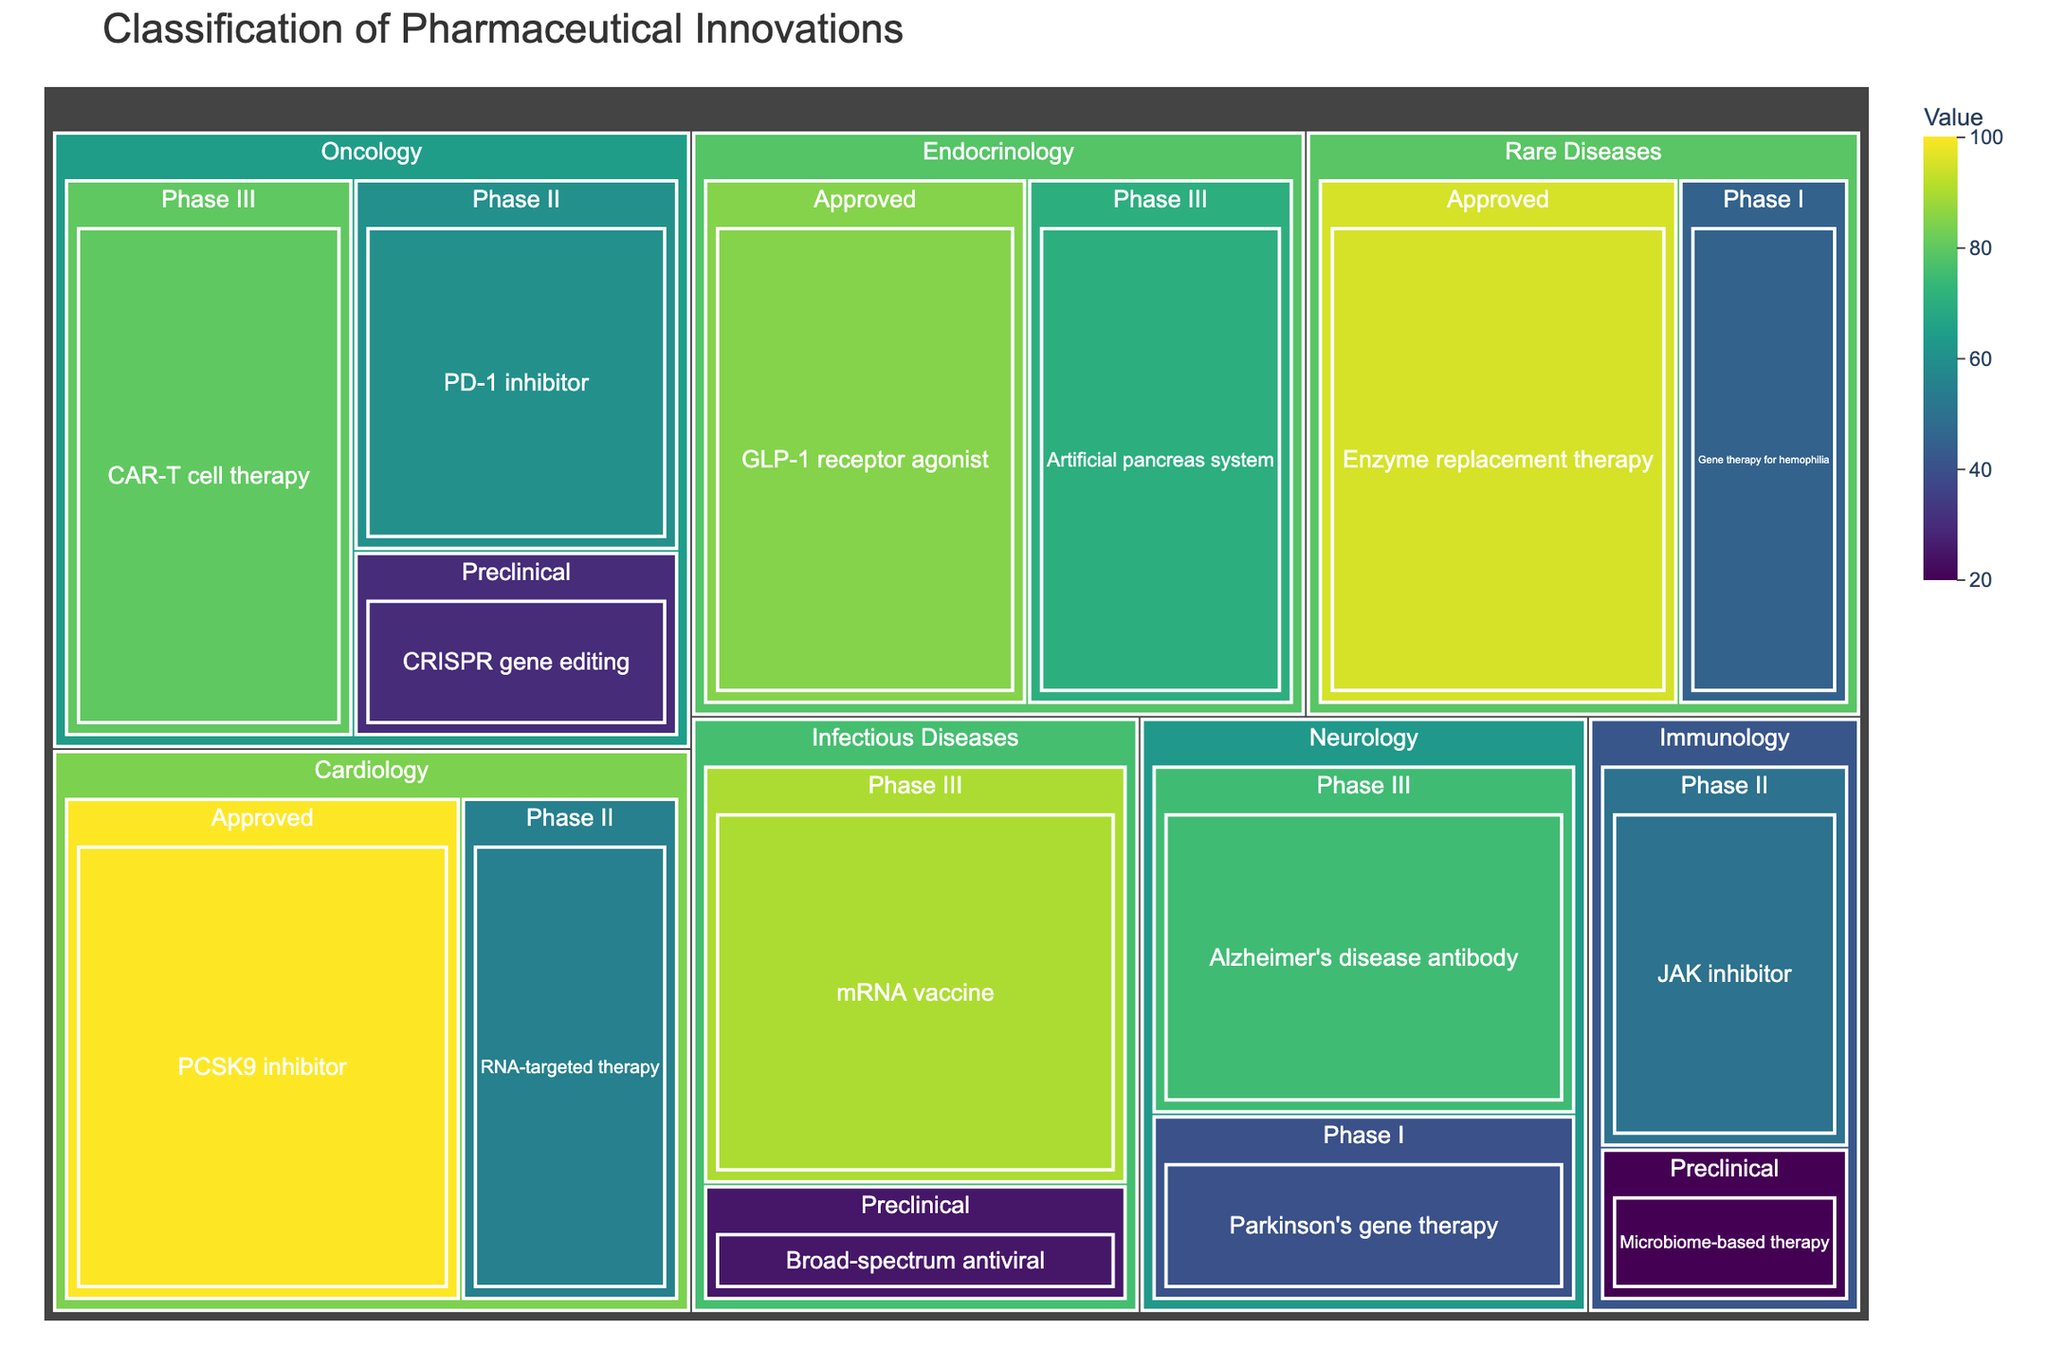what is the title of the figure? The title is located at the top of the figure and gives an overview of what the figure shows. Here, it clearly states that the figure is about the classification of pharmaceutical innovations.
Answer: Classification of Pharmaceutical Innovations Which therapeutic area has the highest value in its Approved stage? By scanning for the nodes labeled "Approved," we see that "Cardiology" has the highest value with 100.
Answer: Cardiology What is the total value of innovations in the Neurology area? Add the values for all the stages within Neurology: Alzheimer's disease antibody (75) + Parkinson's gene therapy (40). The total is 115.
Answer: 115 How does the value of the mRNA vaccine in Phase III, compare to the value of the Alzheimer's disease antibody in Phase III? Look at the values for both innovations, mRNA vaccine has 90 and Alzheimer's disease antibody has 75. The mRNA vaccine has a higher value.
Answer: mRNA vaccine is higher What is the difference in value between the CAR-T cell therapy and the PD-1 inhibitor within Oncology? CAR-T cell therapy has a value of 80 and PD-1 inhibitor has a value of 60. Subtract the smaller value from the larger one: 80 - 60 = 20.
Answer: 20 How many therapeutic areas are shown in the treemap? Count the distinct therapeutic areas listed at the highest hierarchical level: Oncology, Neurology, Cardiology, Infectious Diseases, Rare Diseases, Immunology, Endocrinology. There are 7 such areas.
Answer: 7 Which development stage has the highest number of innovations? Count the number of innovations listed under each development stage. Phase III has 4 innovations (CAR-T cell therapy, Alzheimer's disease antibody, mRNA vaccine, Artificial pancreas system), the highest number.
Answer: Phase III What is the relative proportion of Enzyme replacement therapy value in the Rare Diseases area compared to the total value in Rare Diseases? Enzyme replacement therapy has a value of 95. The total value for Rare Diseases is 95 + 45 = 140. The proportion is 95/140.
Answer: 95/140 Which innovation has the lowest value in the treemap, and what is this value? Look for the smallest value assigned to any innovation. The lowest value is 20, which corresponds to Microbiome-based therapy.
Answer: Microbiome-based therapy with 20 